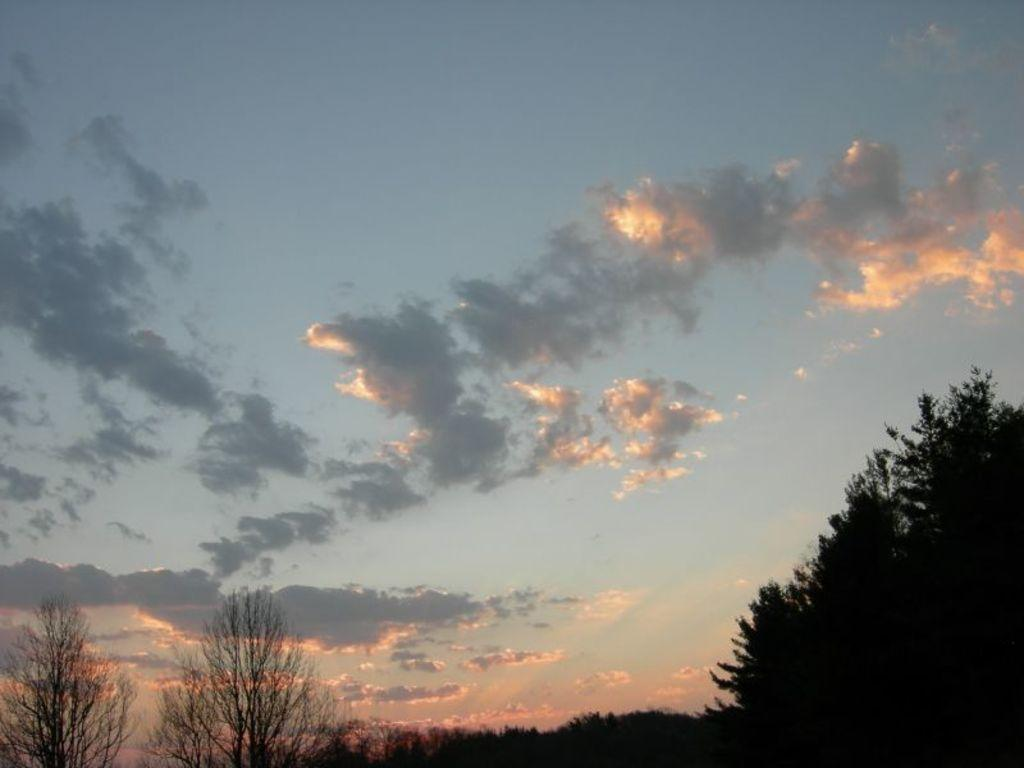What color is the sky in the image? The sky in the image is blue. Are there any additional features in the sky? Yes, there are clouds in the sky. What can be seen at the bottom of the image? Trees are visible at the bottom of the image. What type of worm can be seen crawling on the plate in the image? There is no worm or plate present in the image; it only features the sky and trees. 